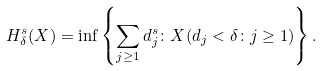<formula> <loc_0><loc_0><loc_500><loc_500>H ^ { s } _ { \delta } ( X ) = \inf \left \{ \sum _ { j \geq 1 } d _ { j } ^ { s } \colon X ( d _ { j } < \delta \colon j \geq 1 ) \right \} .</formula> 